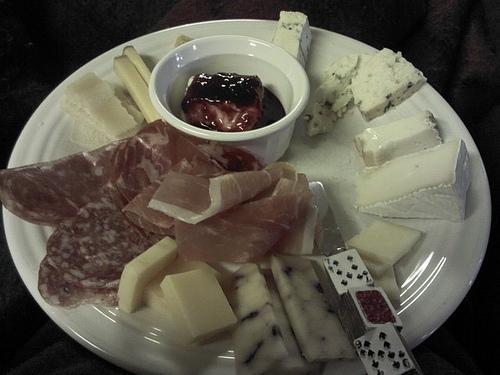How many cards are there?
Give a very brief answer. 3. 